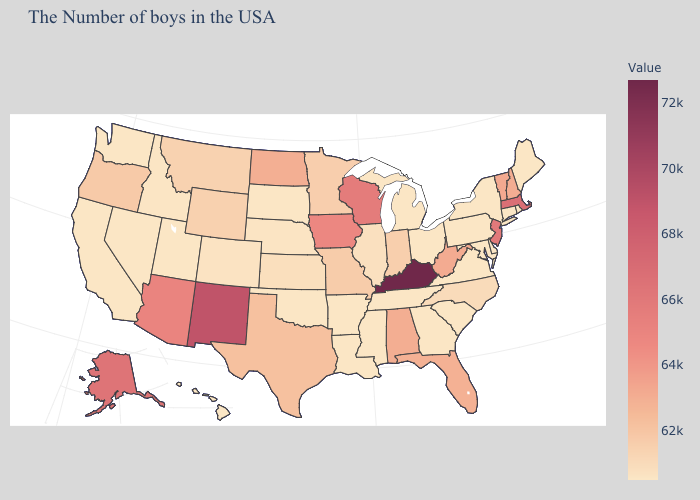Among the states that border Michigan , which have the highest value?
Quick response, please. Wisconsin. Among the states that border West Virginia , which have the lowest value?
Give a very brief answer. Maryland, Pennsylvania, Virginia, Ohio. Does Wisconsin have the highest value in the MidWest?
Short answer required. Yes. Is the legend a continuous bar?
Keep it brief. Yes. Which states have the lowest value in the USA?
Write a very short answer. Maine, Rhode Island, Connecticut, New York, Delaware, Maryland, Pennsylvania, Virginia, South Carolina, Ohio, Georgia, Michigan, Tennessee, Mississippi, Louisiana, Arkansas, Oklahoma, South Dakota, Utah, Nevada, California, Washington, Hawaii. 